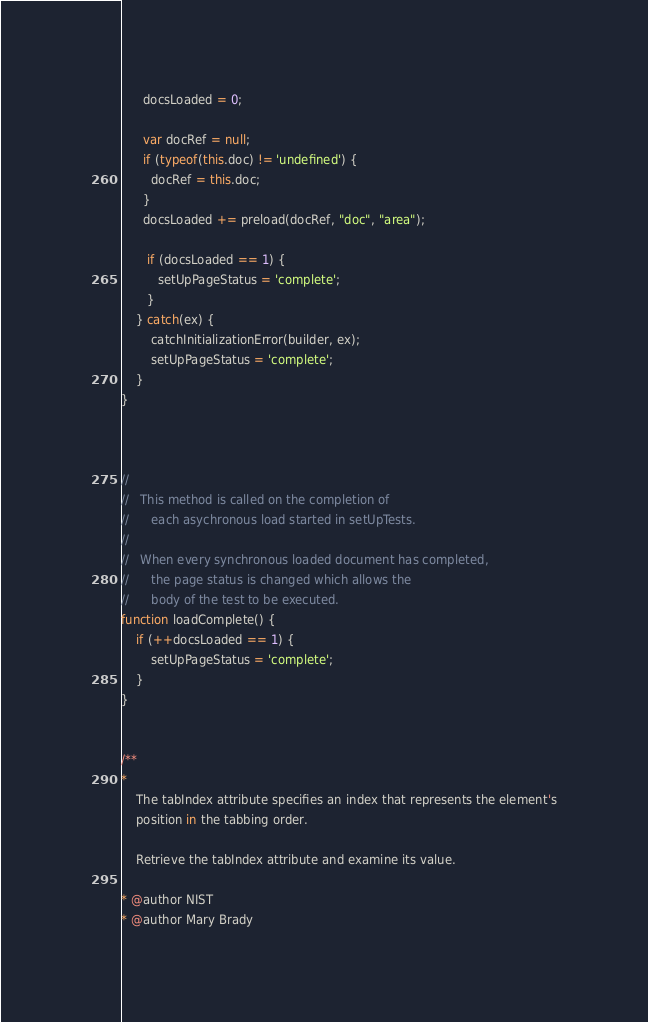<code> <loc_0><loc_0><loc_500><loc_500><_JavaScript_>
      docsLoaded = 0;
      
      var docRef = null;
      if (typeof(this.doc) != 'undefined') {
        docRef = this.doc;
      }
      docsLoaded += preload(docRef, "doc", "area");
        
       if (docsLoaded == 1) {
          setUpPageStatus = 'complete';
       }
    } catch(ex) {
    	catchInitializationError(builder, ex);
        setUpPageStatus = 'complete';
    }
}



//
//   This method is called on the completion of 
//      each asychronous load started in setUpTests.
//
//   When every synchronous loaded document has completed,
//      the page status is changed which allows the
//      body of the test to be executed.
function loadComplete() {
    if (++docsLoaded == 1) {
        setUpPageStatus = 'complete';
    }
}


/**
* 
    The tabIndex attribute specifies an index that represents the element's
    position in the tabbing order.

    Retrieve the tabIndex attribute and examine its value.  

* @author NIST
* @author Mary Brady</code> 